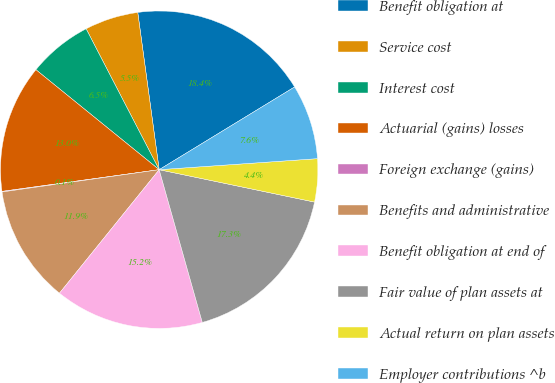<chart> <loc_0><loc_0><loc_500><loc_500><pie_chart><fcel>Benefit obligation at<fcel>Service cost<fcel>Interest cost<fcel>Actuarial (gains) losses<fcel>Foreign exchange (gains)<fcel>Benefits and administrative<fcel>Benefit obligation at end of<fcel>Fair value of plan assets at<fcel>Actual return on plan assets<fcel>Employer contributions ^b<nl><fcel>18.43%<fcel>5.46%<fcel>6.54%<fcel>13.03%<fcel>0.06%<fcel>11.95%<fcel>15.19%<fcel>17.35%<fcel>4.38%<fcel>7.62%<nl></chart> 